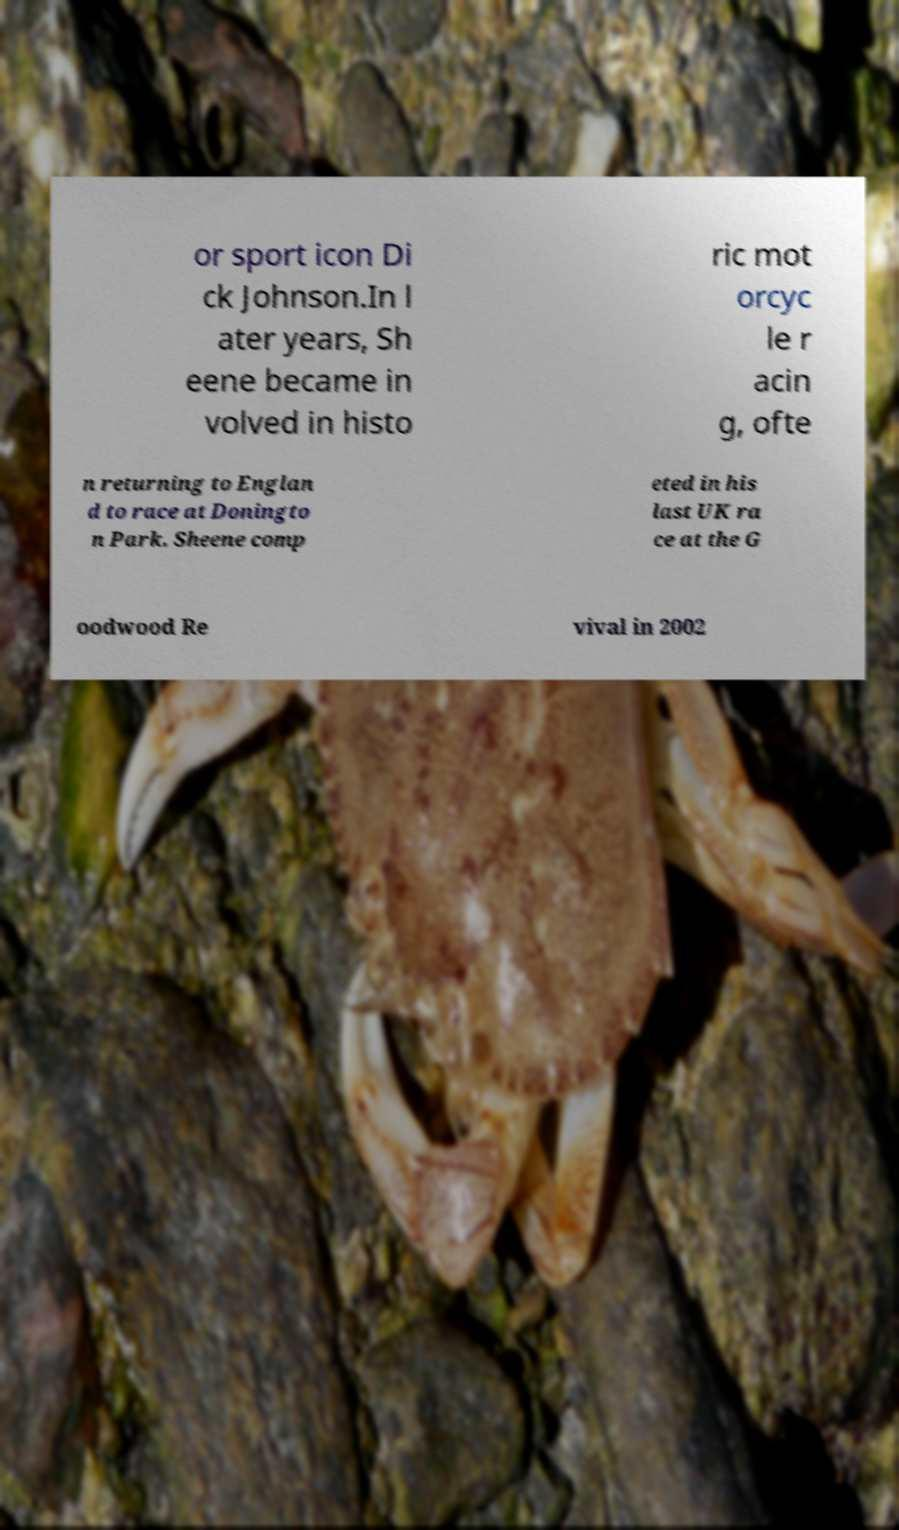Can you read and provide the text displayed in the image?This photo seems to have some interesting text. Can you extract and type it out for me? or sport icon Di ck Johnson.In l ater years, Sh eene became in volved in histo ric mot orcyc le r acin g, ofte n returning to Englan d to race at Doningto n Park. Sheene comp eted in his last UK ra ce at the G oodwood Re vival in 2002 